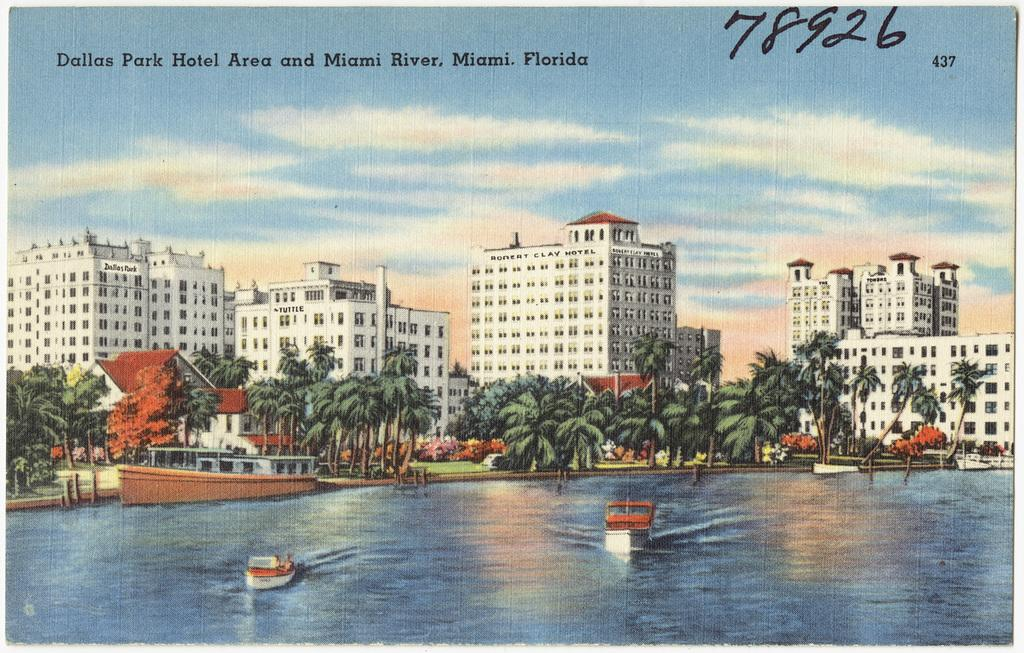What type of visual representation is shown in the image? The image appears to be a poster. What structures are depicted on the poster? There are buildings depicted on the poster. What type of natural elements can be seen on the poster? Trees are visible on the poster. What mode of transportation is present on the water surface in the poster? Ships are present on the water surface in the poster. What part of the environment is visible in the poster? The sky is visible in the poster. How many dogs are blowing bubbles in the image? There are no dogs or bubbles present in the image. 